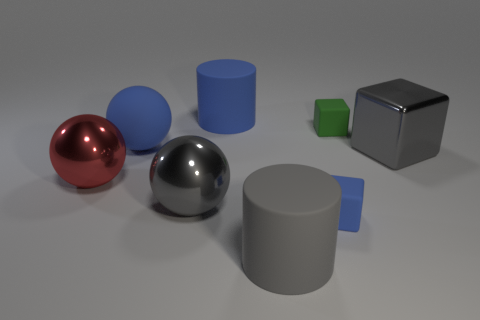There is a gray cylinder that is the same size as the gray sphere; what is it made of?
Your response must be concise. Rubber. Is the color of the big cylinder behind the tiny blue thing the same as the tiny cube that is in front of the big red metallic thing?
Ensure brevity in your answer.  Yes. Is there another small thing that has the same shape as the green rubber object?
Offer a very short reply. Yes. There is another matte thing that is the same size as the green rubber object; what shape is it?
Your answer should be very brief. Cube. What number of large matte cylinders have the same color as the metallic cube?
Give a very brief answer. 1. What is the size of the cylinder in front of the red shiny object?
Your answer should be very brief. Large. What number of brown metallic cylinders have the same size as the blue rubber sphere?
Provide a short and direct response. 0. What color is the other block that is made of the same material as the blue block?
Your response must be concise. Green. Are there fewer big blue spheres behind the green matte thing than large gray matte cylinders?
Your response must be concise. Yes. There is a big gray object that is the same material as the big gray sphere; what shape is it?
Keep it short and to the point. Cube. 